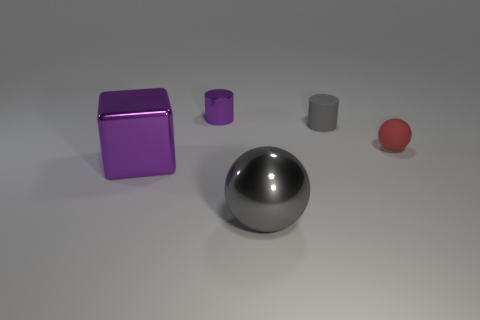Add 5 tiny yellow matte cubes. How many objects exist? 10 Subtract 2 balls. How many balls are left? 0 Subtract all cylinders. How many objects are left? 3 Subtract 0 cyan spheres. How many objects are left? 5 Subtract all cyan cubes. Subtract all purple spheres. How many cubes are left? 1 Subtract all tiny spheres. Subtract all large gray metallic things. How many objects are left? 3 Add 4 large balls. How many large balls are left? 5 Add 5 large purple spheres. How many large purple spheres exist? 5 